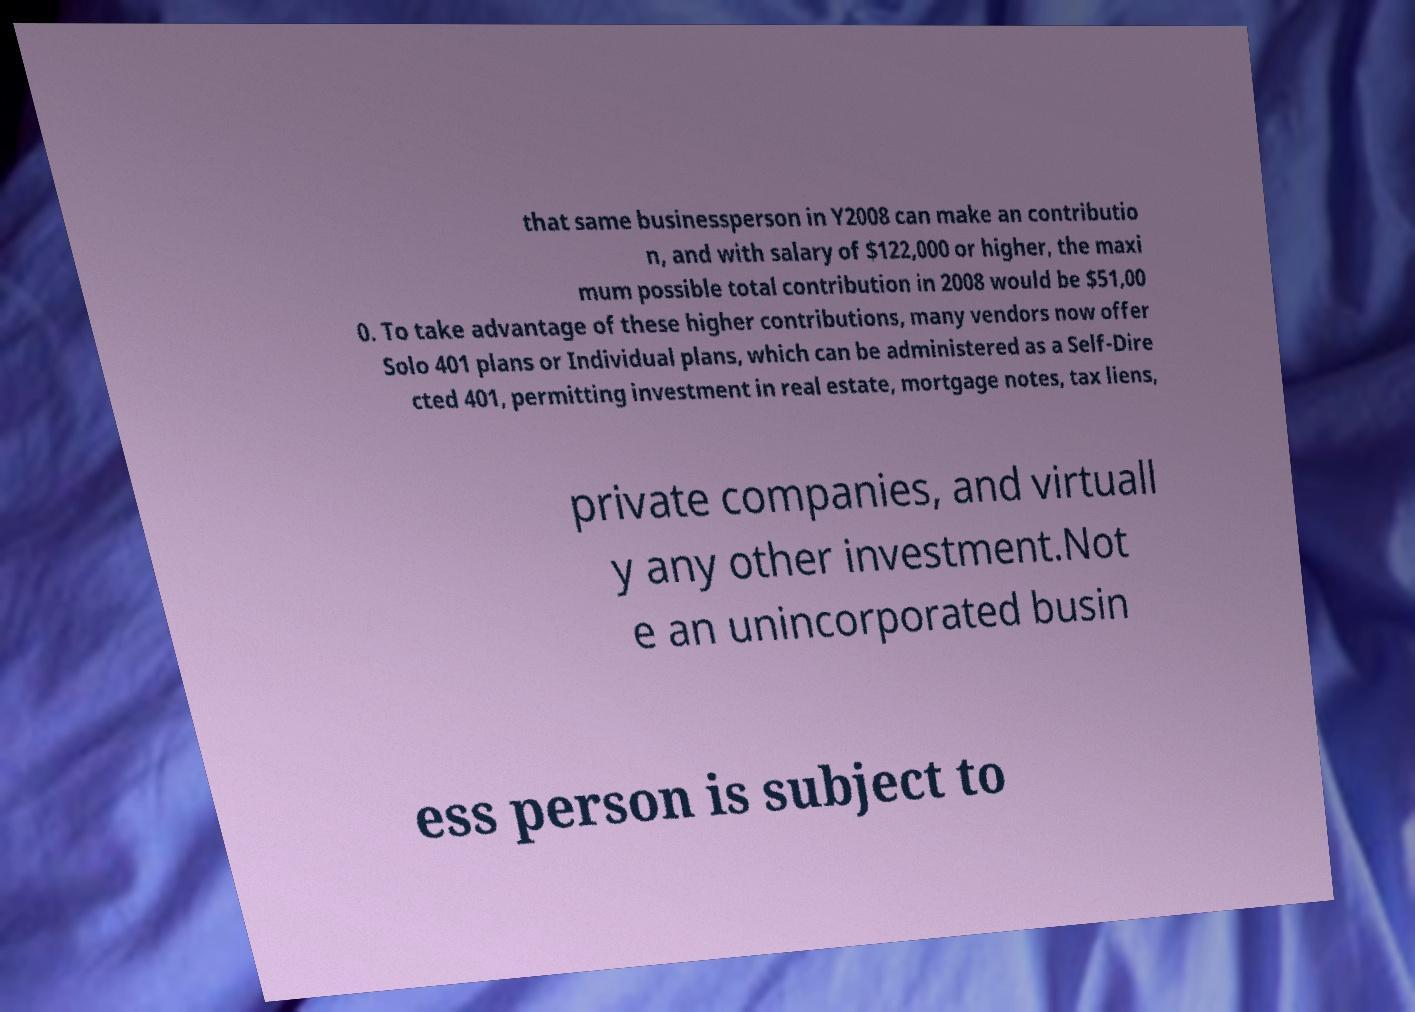Can you read and provide the text displayed in the image?This photo seems to have some interesting text. Can you extract and type it out for me? that same businessperson in Y2008 can make an contributio n, and with salary of $122,000 or higher, the maxi mum possible total contribution in 2008 would be $51,00 0. To take advantage of these higher contributions, many vendors now offer Solo 401 plans or Individual plans, which can be administered as a Self-Dire cted 401, permitting investment in real estate, mortgage notes, tax liens, private companies, and virtuall y any other investment.Not e an unincorporated busin ess person is subject to 